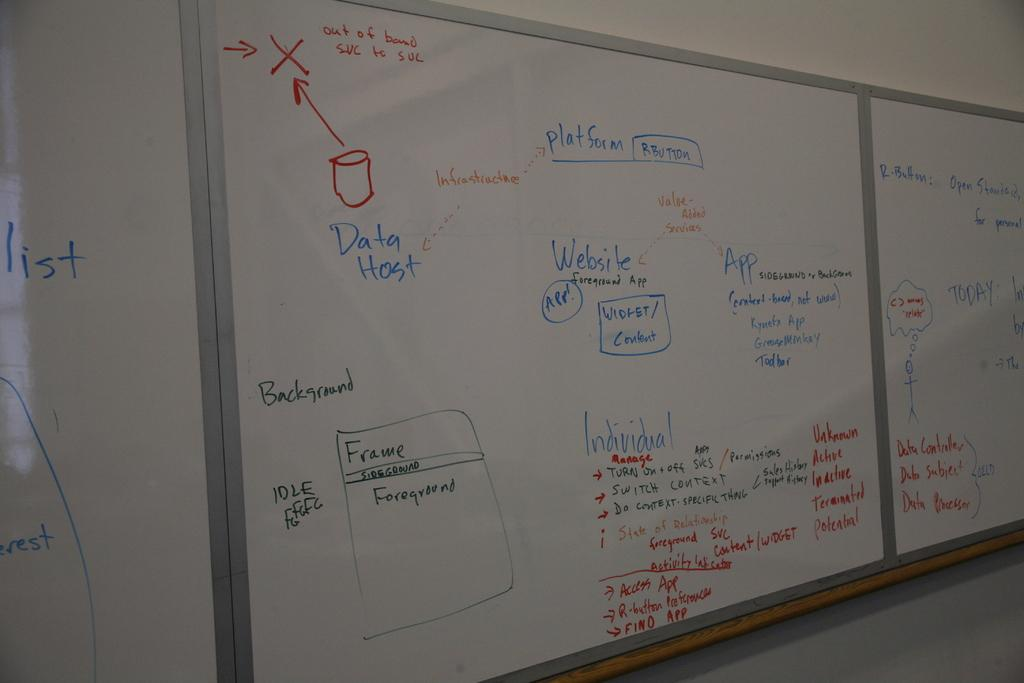<image>
Offer a succinct explanation of the picture presented. The writing on the whiteboard in blue says Data Host 